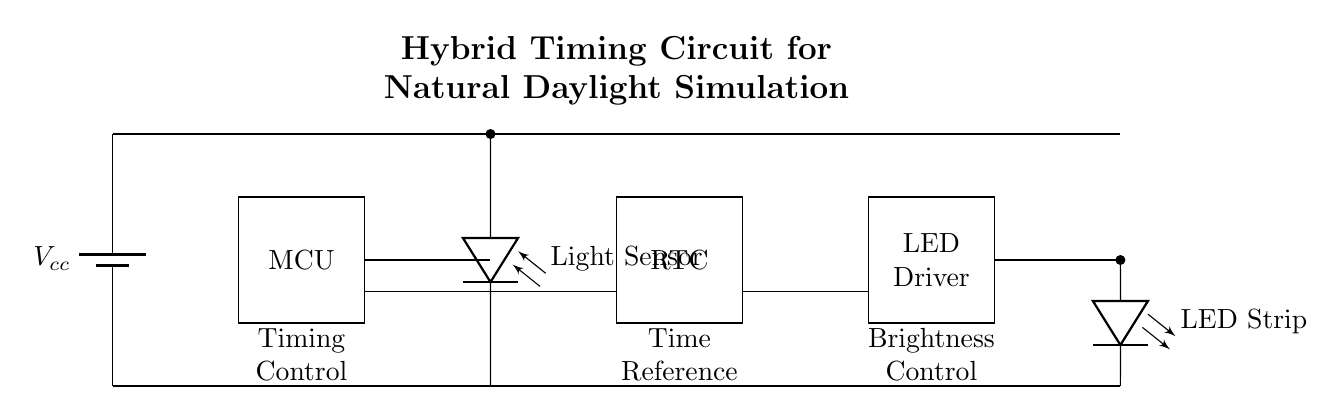What is the primary component controlling the light transitions? The primary component controlling the light transitions is the microcontroller, which manages the timing and brightness adjustments.
Answer: Microcontroller What component is used to detect ambient light? The component used to detect ambient light is the photodiode, which senses the light levels and provides feedback to the microcontroller.
Answer: Photodiode Which component provides real-time clock functionality? The component providing real-time clock functionality is the RTC, which keeps track of the current time to simulate daylight patterns accurately.
Answer: RTC How many main sections are there in the circuit? There are five main sections in the circuit, namely the power supply, microcontroller, light sensor, RTC, and LED driver.
Answer: Five What type of lighting does the circuit simulate? The circuit simulates natural daylight patterns by adjusting the LED brightness throughout the day based on time and ambient light conditions.
Answer: Natural daylight Why is the connection from the microcontroller to the LED driver important? The connection from the microcontroller to the LED driver is important because it allows for real-time adjustments in brightness, enabling the LEDs to mimic natural light transitions based on the time of day.
Answer: Real-time adjustments What purpose does the LED driver serve in this circuit? The LED driver serves to control the power delivered to the LED strip, ensuring appropriate brightness levels based on the input from the microcontroller and the light sensor.
Answer: Brightness control 